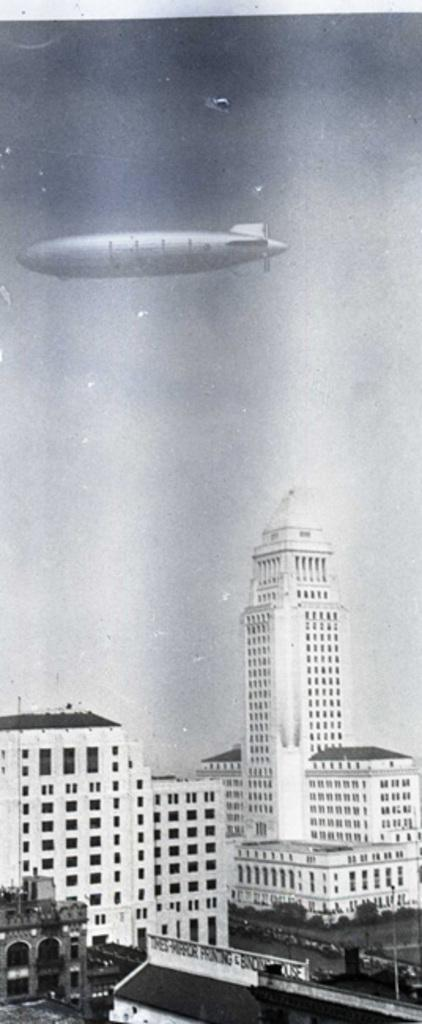What type of structures are visible in the image? There are buildings in the image. What can be seen in the sky in the image? There is an airship in the sky in the image. What is the color scheme of the image? The image is in black and white. What type of food is being cooked in the image? There is no food or cooking activity present in the image. 